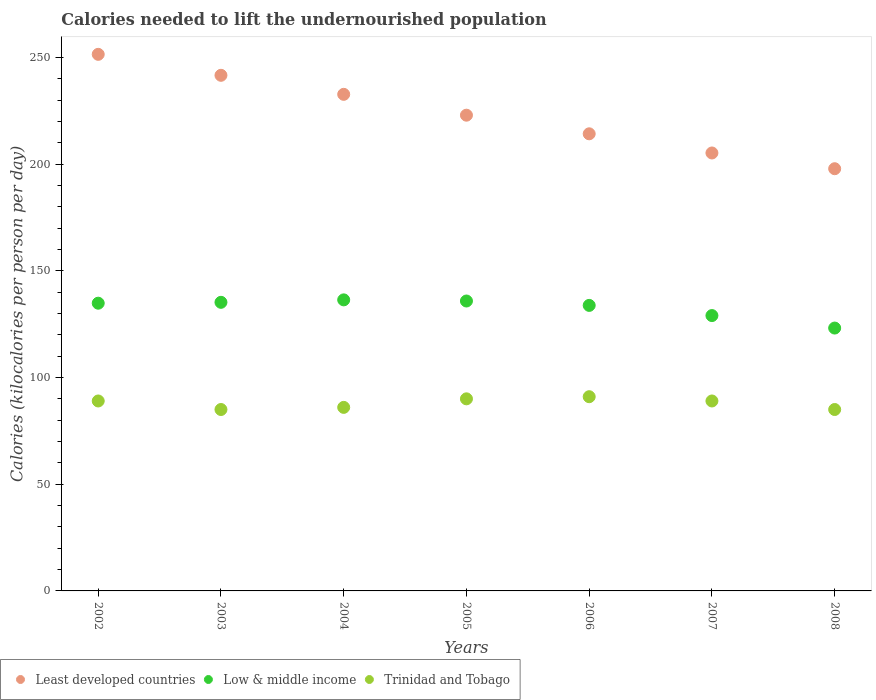How many different coloured dotlines are there?
Offer a very short reply. 3. Is the number of dotlines equal to the number of legend labels?
Offer a terse response. Yes. What is the total calories needed to lift the undernourished population in Trinidad and Tobago in 2008?
Offer a very short reply. 85. Across all years, what is the maximum total calories needed to lift the undernourished population in Trinidad and Tobago?
Your answer should be very brief. 91. Across all years, what is the minimum total calories needed to lift the undernourished population in Trinidad and Tobago?
Offer a terse response. 85. In which year was the total calories needed to lift the undernourished population in Low & middle income maximum?
Give a very brief answer. 2004. In which year was the total calories needed to lift the undernourished population in Least developed countries minimum?
Offer a very short reply. 2008. What is the total total calories needed to lift the undernourished population in Trinidad and Tobago in the graph?
Provide a succinct answer. 615. What is the difference between the total calories needed to lift the undernourished population in Least developed countries in 2006 and that in 2007?
Ensure brevity in your answer.  8.98. What is the difference between the total calories needed to lift the undernourished population in Least developed countries in 2003 and the total calories needed to lift the undernourished population in Low & middle income in 2008?
Provide a short and direct response. 118.43. What is the average total calories needed to lift the undernourished population in Trinidad and Tobago per year?
Provide a succinct answer. 87.86. In the year 2003, what is the difference between the total calories needed to lift the undernourished population in Least developed countries and total calories needed to lift the undernourished population in Trinidad and Tobago?
Your answer should be compact. 156.59. In how many years, is the total calories needed to lift the undernourished population in Trinidad and Tobago greater than 40 kilocalories?
Your answer should be very brief. 7. What is the ratio of the total calories needed to lift the undernourished population in Least developed countries in 2003 to that in 2006?
Ensure brevity in your answer.  1.13. Is the difference between the total calories needed to lift the undernourished population in Least developed countries in 2003 and 2006 greater than the difference between the total calories needed to lift the undernourished population in Trinidad and Tobago in 2003 and 2006?
Ensure brevity in your answer.  Yes. What is the difference between the highest and the lowest total calories needed to lift the undernourished population in Least developed countries?
Your response must be concise. 53.59. In how many years, is the total calories needed to lift the undernourished population in Trinidad and Tobago greater than the average total calories needed to lift the undernourished population in Trinidad and Tobago taken over all years?
Your answer should be compact. 4. Is the sum of the total calories needed to lift the undernourished population in Low & middle income in 2003 and 2004 greater than the maximum total calories needed to lift the undernourished population in Trinidad and Tobago across all years?
Make the answer very short. Yes. Is it the case that in every year, the sum of the total calories needed to lift the undernourished population in Trinidad and Tobago and total calories needed to lift the undernourished population in Low & middle income  is greater than the total calories needed to lift the undernourished population in Least developed countries?
Ensure brevity in your answer.  No. Does the total calories needed to lift the undernourished population in Low & middle income monotonically increase over the years?
Your answer should be very brief. No. How many dotlines are there?
Make the answer very short. 3. What is the difference between two consecutive major ticks on the Y-axis?
Keep it short and to the point. 50. Are the values on the major ticks of Y-axis written in scientific E-notation?
Keep it short and to the point. No. Does the graph contain any zero values?
Provide a short and direct response. No. What is the title of the graph?
Your response must be concise. Calories needed to lift the undernourished population. Does "Costa Rica" appear as one of the legend labels in the graph?
Your answer should be very brief. No. What is the label or title of the X-axis?
Your answer should be very brief. Years. What is the label or title of the Y-axis?
Provide a short and direct response. Calories (kilocalories per person per day). What is the Calories (kilocalories per person per day) in Least developed countries in 2002?
Your response must be concise. 251.42. What is the Calories (kilocalories per person per day) of Low & middle income in 2002?
Your answer should be very brief. 134.81. What is the Calories (kilocalories per person per day) in Trinidad and Tobago in 2002?
Give a very brief answer. 89. What is the Calories (kilocalories per person per day) of Least developed countries in 2003?
Provide a short and direct response. 241.59. What is the Calories (kilocalories per person per day) in Low & middle income in 2003?
Offer a very short reply. 135.22. What is the Calories (kilocalories per person per day) of Least developed countries in 2004?
Offer a terse response. 232.67. What is the Calories (kilocalories per person per day) of Low & middle income in 2004?
Keep it short and to the point. 136.37. What is the Calories (kilocalories per person per day) of Least developed countries in 2005?
Your answer should be compact. 222.9. What is the Calories (kilocalories per person per day) in Low & middle income in 2005?
Provide a succinct answer. 135.84. What is the Calories (kilocalories per person per day) in Least developed countries in 2006?
Make the answer very short. 214.18. What is the Calories (kilocalories per person per day) in Low & middle income in 2006?
Keep it short and to the point. 133.78. What is the Calories (kilocalories per person per day) of Trinidad and Tobago in 2006?
Provide a succinct answer. 91. What is the Calories (kilocalories per person per day) in Least developed countries in 2007?
Ensure brevity in your answer.  205.2. What is the Calories (kilocalories per person per day) in Low & middle income in 2007?
Provide a short and direct response. 129.01. What is the Calories (kilocalories per person per day) of Trinidad and Tobago in 2007?
Make the answer very short. 89. What is the Calories (kilocalories per person per day) in Least developed countries in 2008?
Your answer should be compact. 197.82. What is the Calories (kilocalories per person per day) in Low & middle income in 2008?
Keep it short and to the point. 123.16. What is the Calories (kilocalories per person per day) in Trinidad and Tobago in 2008?
Offer a very short reply. 85. Across all years, what is the maximum Calories (kilocalories per person per day) in Least developed countries?
Make the answer very short. 251.42. Across all years, what is the maximum Calories (kilocalories per person per day) of Low & middle income?
Your answer should be compact. 136.37. Across all years, what is the maximum Calories (kilocalories per person per day) of Trinidad and Tobago?
Provide a succinct answer. 91. Across all years, what is the minimum Calories (kilocalories per person per day) in Least developed countries?
Make the answer very short. 197.82. Across all years, what is the minimum Calories (kilocalories per person per day) of Low & middle income?
Offer a very short reply. 123.16. What is the total Calories (kilocalories per person per day) in Least developed countries in the graph?
Provide a short and direct response. 1565.79. What is the total Calories (kilocalories per person per day) in Low & middle income in the graph?
Your answer should be compact. 928.21. What is the total Calories (kilocalories per person per day) in Trinidad and Tobago in the graph?
Provide a succinct answer. 615. What is the difference between the Calories (kilocalories per person per day) of Least developed countries in 2002 and that in 2003?
Offer a terse response. 9.83. What is the difference between the Calories (kilocalories per person per day) in Low & middle income in 2002 and that in 2003?
Make the answer very short. -0.41. What is the difference between the Calories (kilocalories per person per day) of Least developed countries in 2002 and that in 2004?
Make the answer very short. 18.74. What is the difference between the Calories (kilocalories per person per day) of Low & middle income in 2002 and that in 2004?
Offer a terse response. -1.56. What is the difference between the Calories (kilocalories per person per day) in Least developed countries in 2002 and that in 2005?
Provide a succinct answer. 28.51. What is the difference between the Calories (kilocalories per person per day) in Low & middle income in 2002 and that in 2005?
Offer a terse response. -1.03. What is the difference between the Calories (kilocalories per person per day) in Least developed countries in 2002 and that in 2006?
Give a very brief answer. 37.24. What is the difference between the Calories (kilocalories per person per day) in Low & middle income in 2002 and that in 2006?
Make the answer very short. 1.03. What is the difference between the Calories (kilocalories per person per day) of Least developed countries in 2002 and that in 2007?
Ensure brevity in your answer.  46.22. What is the difference between the Calories (kilocalories per person per day) in Low & middle income in 2002 and that in 2007?
Your response must be concise. 5.8. What is the difference between the Calories (kilocalories per person per day) of Trinidad and Tobago in 2002 and that in 2007?
Your answer should be very brief. 0. What is the difference between the Calories (kilocalories per person per day) in Least developed countries in 2002 and that in 2008?
Your response must be concise. 53.59. What is the difference between the Calories (kilocalories per person per day) in Low & middle income in 2002 and that in 2008?
Your answer should be compact. 11.65. What is the difference between the Calories (kilocalories per person per day) of Trinidad and Tobago in 2002 and that in 2008?
Offer a very short reply. 4. What is the difference between the Calories (kilocalories per person per day) in Least developed countries in 2003 and that in 2004?
Your answer should be very brief. 8.92. What is the difference between the Calories (kilocalories per person per day) of Low & middle income in 2003 and that in 2004?
Your answer should be very brief. -1.15. What is the difference between the Calories (kilocalories per person per day) of Least developed countries in 2003 and that in 2005?
Provide a short and direct response. 18.69. What is the difference between the Calories (kilocalories per person per day) in Low & middle income in 2003 and that in 2005?
Your answer should be compact. -0.62. What is the difference between the Calories (kilocalories per person per day) in Trinidad and Tobago in 2003 and that in 2005?
Offer a terse response. -5. What is the difference between the Calories (kilocalories per person per day) in Least developed countries in 2003 and that in 2006?
Your answer should be very brief. 27.41. What is the difference between the Calories (kilocalories per person per day) of Low & middle income in 2003 and that in 2006?
Your answer should be very brief. 1.44. What is the difference between the Calories (kilocalories per person per day) of Trinidad and Tobago in 2003 and that in 2006?
Make the answer very short. -6. What is the difference between the Calories (kilocalories per person per day) in Least developed countries in 2003 and that in 2007?
Give a very brief answer. 36.39. What is the difference between the Calories (kilocalories per person per day) of Low & middle income in 2003 and that in 2007?
Your answer should be very brief. 6.21. What is the difference between the Calories (kilocalories per person per day) in Least developed countries in 2003 and that in 2008?
Your answer should be very brief. 43.77. What is the difference between the Calories (kilocalories per person per day) of Low & middle income in 2003 and that in 2008?
Provide a short and direct response. 12.06. What is the difference between the Calories (kilocalories per person per day) in Trinidad and Tobago in 2003 and that in 2008?
Keep it short and to the point. 0. What is the difference between the Calories (kilocalories per person per day) in Least developed countries in 2004 and that in 2005?
Offer a terse response. 9.77. What is the difference between the Calories (kilocalories per person per day) in Low & middle income in 2004 and that in 2005?
Provide a succinct answer. 0.54. What is the difference between the Calories (kilocalories per person per day) in Least developed countries in 2004 and that in 2006?
Provide a short and direct response. 18.49. What is the difference between the Calories (kilocalories per person per day) of Low & middle income in 2004 and that in 2006?
Your answer should be very brief. 2.59. What is the difference between the Calories (kilocalories per person per day) of Least developed countries in 2004 and that in 2007?
Offer a very short reply. 27.47. What is the difference between the Calories (kilocalories per person per day) in Low & middle income in 2004 and that in 2007?
Give a very brief answer. 7.36. What is the difference between the Calories (kilocalories per person per day) of Trinidad and Tobago in 2004 and that in 2007?
Ensure brevity in your answer.  -3. What is the difference between the Calories (kilocalories per person per day) of Least developed countries in 2004 and that in 2008?
Your answer should be very brief. 34.85. What is the difference between the Calories (kilocalories per person per day) in Low & middle income in 2004 and that in 2008?
Offer a very short reply. 13.21. What is the difference between the Calories (kilocalories per person per day) in Trinidad and Tobago in 2004 and that in 2008?
Provide a short and direct response. 1. What is the difference between the Calories (kilocalories per person per day) in Least developed countries in 2005 and that in 2006?
Give a very brief answer. 8.72. What is the difference between the Calories (kilocalories per person per day) in Low & middle income in 2005 and that in 2006?
Your response must be concise. 2.06. What is the difference between the Calories (kilocalories per person per day) in Least developed countries in 2005 and that in 2007?
Provide a succinct answer. 17.7. What is the difference between the Calories (kilocalories per person per day) in Low & middle income in 2005 and that in 2007?
Ensure brevity in your answer.  6.83. What is the difference between the Calories (kilocalories per person per day) of Trinidad and Tobago in 2005 and that in 2007?
Keep it short and to the point. 1. What is the difference between the Calories (kilocalories per person per day) in Least developed countries in 2005 and that in 2008?
Your response must be concise. 25.08. What is the difference between the Calories (kilocalories per person per day) of Low & middle income in 2005 and that in 2008?
Make the answer very short. 12.68. What is the difference between the Calories (kilocalories per person per day) of Least developed countries in 2006 and that in 2007?
Provide a short and direct response. 8.98. What is the difference between the Calories (kilocalories per person per day) in Low & middle income in 2006 and that in 2007?
Make the answer very short. 4.77. What is the difference between the Calories (kilocalories per person per day) in Trinidad and Tobago in 2006 and that in 2007?
Offer a very short reply. 2. What is the difference between the Calories (kilocalories per person per day) of Least developed countries in 2006 and that in 2008?
Offer a terse response. 16.36. What is the difference between the Calories (kilocalories per person per day) in Low & middle income in 2006 and that in 2008?
Offer a very short reply. 10.62. What is the difference between the Calories (kilocalories per person per day) of Least developed countries in 2007 and that in 2008?
Provide a succinct answer. 7.38. What is the difference between the Calories (kilocalories per person per day) of Low & middle income in 2007 and that in 2008?
Give a very brief answer. 5.85. What is the difference between the Calories (kilocalories per person per day) in Least developed countries in 2002 and the Calories (kilocalories per person per day) in Low & middle income in 2003?
Provide a succinct answer. 116.19. What is the difference between the Calories (kilocalories per person per day) in Least developed countries in 2002 and the Calories (kilocalories per person per day) in Trinidad and Tobago in 2003?
Provide a short and direct response. 166.42. What is the difference between the Calories (kilocalories per person per day) of Low & middle income in 2002 and the Calories (kilocalories per person per day) of Trinidad and Tobago in 2003?
Your answer should be compact. 49.81. What is the difference between the Calories (kilocalories per person per day) of Least developed countries in 2002 and the Calories (kilocalories per person per day) of Low & middle income in 2004?
Provide a short and direct response. 115.04. What is the difference between the Calories (kilocalories per person per day) of Least developed countries in 2002 and the Calories (kilocalories per person per day) of Trinidad and Tobago in 2004?
Provide a short and direct response. 165.42. What is the difference between the Calories (kilocalories per person per day) in Low & middle income in 2002 and the Calories (kilocalories per person per day) in Trinidad and Tobago in 2004?
Offer a very short reply. 48.81. What is the difference between the Calories (kilocalories per person per day) in Least developed countries in 2002 and the Calories (kilocalories per person per day) in Low & middle income in 2005?
Provide a short and direct response. 115.58. What is the difference between the Calories (kilocalories per person per day) of Least developed countries in 2002 and the Calories (kilocalories per person per day) of Trinidad and Tobago in 2005?
Make the answer very short. 161.42. What is the difference between the Calories (kilocalories per person per day) in Low & middle income in 2002 and the Calories (kilocalories per person per day) in Trinidad and Tobago in 2005?
Keep it short and to the point. 44.81. What is the difference between the Calories (kilocalories per person per day) in Least developed countries in 2002 and the Calories (kilocalories per person per day) in Low & middle income in 2006?
Make the answer very short. 117.63. What is the difference between the Calories (kilocalories per person per day) in Least developed countries in 2002 and the Calories (kilocalories per person per day) in Trinidad and Tobago in 2006?
Keep it short and to the point. 160.42. What is the difference between the Calories (kilocalories per person per day) of Low & middle income in 2002 and the Calories (kilocalories per person per day) of Trinidad and Tobago in 2006?
Your response must be concise. 43.81. What is the difference between the Calories (kilocalories per person per day) in Least developed countries in 2002 and the Calories (kilocalories per person per day) in Low & middle income in 2007?
Offer a terse response. 122.4. What is the difference between the Calories (kilocalories per person per day) in Least developed countries in 2002 and the Calories (kilocalories per person per day) in Trinidad and Tobago in 2007?
Ensure brevity in your answer.  162.42. What is the difference between the Calories (kilocalories per person per day) in Low & middle income in 2002 and the Calories (kilocalories per person per day) in Trinidad and Tobago in 2007?
Give a very brief answer. 45.81. What is the difference between the Calories (kilocalories per person per day) of Least developed countries in 2002 and the Calories (kilocalories per person per day) of Low & middle income in 2008?
Give a very brief answer. 128.25. What is the difference between the Calories (kilocalories per person per day) of Least developed countries in 2002 and the Calories (kilocalories per person per day) of Trinidad and Tobago in 2008?
Make the answer very short. 166.42. What is the difference between the Calories (kilocalories per person per day) of Low & middle income in 2002 and the Calories (kilocalories per person per day) of Trinidad and Tobago in 2008?
Ensure brevity in your answer.  49.81. What is the difference between the Calories (kilocalories per person per day) of Least developed countries in 2003 and the Calories (kilocalories per person per day) of Low & middle income in 2004?
Your response must be concise. 105.22. What is the difference between the Calories (kilocalories per person per day) of Least developed countries in 2003 and the Calories (kilocalories per person per day) of Trinidad and Tobago in 2004?
Provide a succinct answer. 155.59. What is the difference between the Calories (kilocalories per person per day) in Low & middle income in 2003 and the Calories (kilocalories per person per day) in Trinidad and Tobago in 2004?
Your response must be concise. 49.22. What is the difference between the Calories (kilocalories per person per day) in Least developed countries in 2003 and the Calories (kilocalories per person per day) in Low & middle income in 2005?
Make the answer very short. 105.75. What is the difference between the Calories (kilocalories per person per day) in Least developed countries in 2003 and the Calories (kilocalories per person per day) in Trinidad and Tobago in 2005?
Your response must be concise. 151.59. What is the difference between the Calories (kilocalories per person per day) of Low & middle income in 2003 and the Calories (kilocalories per person per day) of Trinidad and Tobago in 2005?
Your answer should be very brief. 45.22. What is the difference between the Calories (kilocalories per person per day) of Least developed countries in 2003 and the Calories (kilocalories per person per day) of Low & middle income in 2006?
Offer a very short reply. 107.81. What is the difference between the Calories (kilocalories per person per day) of Least developed countries in 2003 and the Calories (kilocalories per person per day) of Trinidad and Tobago in 2006?
Give a very brief answer. 150.59. What is the difference between the Calories (kilocalories per person per day) in Low & middle income in 2003 and the Calories (kilocalories per person per day) in Trinidad and Tobago in 2006?
Your answer should be very brief. 44.22. What is the difference between the Calories (kilocalories per person per day) in Least developed countries in 2003 and the Calories (kilocalories per person per day) in Low & middle income in 2007?
Your answer should be compact. 112.58. What is the difference between the Calories (kilocalories per person per day) of Least developed countries in 2003 and the Calories (kilocalories per person per day) of Trinidad and Tobago in 2007?
Your answer should be compact. 152.59. What is the difference between the Calories (kilocalories per person per day) in Low & middle income in 2003 and the Calories (kilocalories per person per day) in Trinidad and Tobago in 2007?
Your answer should be very brief. 46.22. What is the difference between the Calories (kilocalories per person per day) in Least developed countries in 2003 and the Calories (kilocalories per person per day) in Low & middle income in 2008?
Make the answer very short. 118.43. What is the difference between the Calories (kilocalories per person per day) in Least developed countries in 2003 and the Calories (kilocalories per person per day) in Trinidad and Tobago in 2008?
Provide a short and direct response. 156.59. What is the difference between the Calories (kilocalories per person per day) of Low & middle income in 2003 and the Calories (kilocalories per person per day) of Trinidad and Tobago in 2008?
Provide a short and direct response. 50.22. What is the difference between the Calories (kilocalories per person per day) of Least developed countries in 2004 and the Calories (kilocalories per person per day) of Low & middle income in 2005?
Offer a very short reply. 96.83. What is the difference between the Calories (kilocalories per person per day) in Least developed countries in 2004 and the Calories (kilocalories per person per day) in Trinidad and Tobago in 2005?
Offer a very short reply. 142.67. What is the difference between the Calories (kilocalories per person per day) in Low & middle income in 2004 and the Calories (kilocalories per person per day) in Trinidad and Tobago in 2005?
Ensure brevity in your answer.  46.38. What is the difference between the Calories (kilocalories per person per day) in Least developed countries in 2004 and the Calories (kilocalories per person per day) in Low & middle income in 2006?
Provide a succinct answer. 98.89. What is the difference between the Calories (kilocalories per person per day) of Least developed countries in 2004 and the Calories (kilocalories per person per day) of Trinidad and Tobago in 2006?
Your response must be concise. 141.67. What is the difference between the Calories (kilocalories per person per day) in Low & middle income in 2004 and the Calories (kilocalories per person per day) in Trinidad and Tobago in 2006?
Make the answer very short. 45.38. What is the difference between the Calories (kilocalories per person per day) of Least developed countries in 2004 and the Calories (kilocalories per person per day) of Low & middle income in 2007?
Ensure brevity in your answer.  103.66. What is the difference between the Calories (kilocalories per person per day) in Least developed countries in 2004 and the Calories (kilocalories per person per day) in Trinidad and Tobago in 2007?
Your answer should be compact. 143.67. What is the difference between the Calories (kilocalories per person per day) in Low & middle income in 2004 and the Calories (kilocalories per person per day) in Trinidad and Tobago in 2007?
Offer a terse response. 47.38. What is the difference between the Calories (kilocalories per person per day) of Least developed countries in 2004 and the Calories (kilocalories per person per day) of Low & middle income in 2008?
Offer a very short reply. 109.51. What is the difference between the Calories (kilocalories per person per day) of Least developed countries in 2004 and the Calories (kilocalories per person per day) of Trinidad and Tobago in 2008?
Your response must be concise. 147.67. What is the difference between the Calories (kilocalories per person per day) in Low & middle income in 2004 and the Calories (kilocalories per person per day) in Trinidad and Tobago in 2008?
Make the answer very short. 51.38. What is the difference between the Calories (kilocalories per person per day) of Least developed countries in 2005 and the Calories (kilocalories per person per day) of Low & middle income in 2006?
Your response must be concise. 89.12. What is the difference between the Calories (kilocalories per person per day) of Least developed countries in 2005 and the Calories (kilocalories per person per day) of Trinidad and Tobago in 2006?
Make the answer very short. 131.9. What is the difference between the Calories (kilocalories per person per day) in Low & middle income in 2005 and the Calories (kilocalories per person per day) in Trinidad and Tobago in 2006?
Your answer should be compact. 44.84. What is the difference between the Calories (kilocalories per person per day) in Least developed countries in 2005 and the Calories (kilocalories per person per day) in Low & middle income in 2007?
Make the answer very short. 93.89. What is the difference between the Calories (kilocalories per person per day) in Least developed countries in 2005 and the Calories (kilocalories per person per day) in Trinidad and Tobago in 2007?
Give a very brief answer. 133.9. What is the difference between the Calories (kilocalories per person per day) in Low & middle income in 2005 and the Calories (kilocalories per person per day) in Trinidad and Tobago in 2007?
Your answer should be very brief. 46.84. What is the difference between the Calories (kilocalories per person per day) in Least developed countries in 2005 and the Calories (kilocalories per person per day) in Low & middle income in 2008?
Offer a terse response. 99.74. What is the difference between the Calories (kilocalories per person per day) of Least developed countries in 2005 and the Calories (kilocalories per person per day) of Trinidad and Tobago in 2008?
Give a very brief answer. 137.9. What is the difference between the Calories (kilocalories per person per day) of Low & middle income in 2005 and the Calories (kilocalories per person per day) of Trinidad and Tobago in 2008?
Give a very brief answer. 50.84. What is the difference between the Calories (kilocalories per person per day) of Least developed countries in 2006 and the Calories (kilocalories per person per day) of Low & middle income in 2007?
Your response must be concise. 85.17. What is the difference between the Calories (kilocalories per person per day) in Least developed countries in 2006 and the Calories (kilocalories per person per day) in Trinidad and Tobago in 2007?
Offer a very short reply. 125.18. What is the difference between the Calories (kilocalories per person per day) of Low & middle income in 2006 and the Calories (kilocalories per person per day) of Trinidad and Tobago in 2007?
Provide a short and direct response. 44.78. What is the difference between the Calories (kilocalories per person per day) in Least developed countries in 2006 and the Calories (kilocalories per person per day) in Low & middle income in 2008?
Offer a very short reply. 91.02. What is the difference between the Calories (kilocalories per person per day) in Least developed countries in 2006 and the Calories (kilocalories per person per day) in Trinidad and Tobago in 2008?
Your answer should be very brief. 129.18. What is the difference between the Calories (kilocalories per person per day) in Low & middle income in 2006 and the Calories (kilocalories per person per day) in Trinidad and Tobago in 2008?
Provide a short and direct response. 48.78. What is the difference between the Calories (kilocalories per person per day) in Least developed countries in 2007 and the Calories (kilocalories per person per day) in Low & middle income in 2008?
Your response must be concise. 82.04. What is the difference between the Calories (kilocalories per person per day) in Least developed countries in 2007 and the Calories (kilocalories per person per day) in Trinidad and Tobago in 2008?
Provide a succinct answer. 120.2. What is the difference between the Calories (kilocalories per person per day) in Low & middle income in 2007 and the Calories (kilocalories per person per day) in Trinidad and Tobago in 2008?
Your response must be concise. 44.01. What is the average Calories (kilocalories per person per day) of Least developed countries per year?
Offer a terse response. 223.68. What is the average Calories (kilocalories per person per day) in Low & middle income per year?
Your answer should be very brief. 132.6. What is the average Calories (kilocalories per person per day) of Trinidad and Tobago per year?
Your answer should be very brief. 87.86. In the year 2002, what is the difference between the Calories (kilocalories per person per day) in Least developed countries and Calories (kilocalories per person per day) in Low & middle income?
Your answer should be very brief. 116.61. In the year 2002, what is the difference between the Calories (kilocalories per person per day) in Least developed countries and Calories (kilocalories per person per day) in Trinidad and Tobago?
Your answer should be very brief. 162.42. In the year 2002, what is the difference between the Calories (kilocalories per person per day) in Low & middle income and Calories (kilocalories per person per day) in Trinidad and Tobago?
Make the answer very short. 45.81. In the year 2003, what is the difference between the Calories (kilocalories per person per day) of Least developed countries and Calories (kilocalories per person per day) of Low & middle income?
Give a very brief answer. 106.37. In the year 2003, what is the difference between the Calories (kilocalories per person per day) in Least developed countries and Calories (kilocalories per person per day) in Trinidad and Tobago?
Your response must be concise. 156.59. In the year 2003, what is the difference between the Calories (kilocalories per person per day) of Low & middle income and Calories (kilocalories per person per day) of Trinidad and Tobago?
Your response must be concise. 50.22. In the year 2004, what is the difference between the Calories (kilocalories per person per day) in Least developed countries and Calories (kilocalories per person per day) in Low & middle income?
Provide a short and direct response. 96.3. In the year 2004, what is the difference between the Calories (kilocalories per person per day) in Least developed countries and Calories (kilocalories per person per day) in Trinidad and Tobago?
Give a very brief answer. 146.67. In the year 2004, what is the difference between the Calories (kilocalories per person per day) in Low & middle income and Calories (kilocalories per person per day) in Trinidad and Tobago?
Provide a succinct answer. 50.38. In the year 2005, what is the difference between the Calories (kilocalories per person per day) in Least developed countries and Calories (kilocalories per person per day) in Low & middle income?
Offer a terse response. 87.06. In the year 2005, what is the difference between the Calories (kilocalories per person per day) of Least developed countries and Calories (kilocalories per person per day) of Trinidad and Tobago?
Your answer should be very brief. 132.9. In the year 2005, what is the difference between the Calories (kilocalories per person per day) of Low & middle income and Calories (kilocalories per person per day) of Trinidad and Tobago?
Give a very brief answer. 45.84. In the year 2006, what is the difference between the Calories (kilocalories per person per day) of Least developed countries and Calories (kilocalories per person per day) of Low & middle income?
Ensure brevity in your answer.  80.4. In the year 2006, what is the difference between the Calories (kilocalories per person per day) of Least developed countries and Calories (kilocalories per person per day) of Trinidad and Tobago?
Give a very brief answer. 123.18. In the year 2006, what is the difference between the Calories (kilocalories per person per day) of Low & middle income and Calories (kilocalories per person per day) of Trinidad and Tobago?
Keep it short and to the point. 42.78. In the year 2007, what is the difference between the Calories (kilocalories per person per day) of Least developed countries and Calories (kilocalories per person per day) of Low & middle income?
Make the answer very short. 76.19. In the year 2007, what is the difference between the Calories (kilocalories per person per day) in Least developed countries and Calories (kilocalories per person per day) in Trinidad and Tobago?
Your answer should be compact. 116.2. In the year 2007, what is the difference between the Calories (kilocalories per person per day) of Low & middle income and Calories (kilocalories per person per day) of Trinidad and Tobago?
Offer a terse response. 40.01. In the year 2008, what is the difference between the Calories (kilocalories per person per day) of Least developed countries and Calories (kilocalories per person per day) of Low & middle income?
Your response must be concise. 74.66. In the year 2008, what is the difference between the Calories (kilocalories per person per day) in Least developed countries and Calories (kilocalories per person per day) in Trinidad and Tobago?
Ensure brevity in your answer.  112.82. In the year 2008, what is the difference between the Calories (kilocalories per person per day) in Low & middle income and Calories (kilocalories per person per day) in Trinidad and Tobago?
Provide a succinct answer. 38.16. What is the ratio of the Calories (kilocalories per person per day) of Least developed countries in 2002 to that in 2003?
Provide a succinct answer. 1.04. What is the ratio of the Calories (kilocalories per person per day) of Trinidad and Tobago in 2002 to that in 2003?
Your answer should be very brief. 1.05. What is the ratio of the Calories (kilocalories per person per day) of Least developed countries in 2002 to that in 2004?
Your answer should be very brief. 1.08. What is the ratio of the Calories (kilocalories per person per day) of Trinidad and Tobago in 2002 to that in 2004?
Your response must be concise. 1.03. What is the ratio of the Calories (kilocalories per person per day) of Least developed countries in 2002 to that in 2005?
Your answer should be very brief. 1.13. What is the ratio of the Calories (kilocalories per person per day) of Low & middle income in 2002 to that in 2005?
Your answer should be very brief. 0.99. What is the ratio of the Calories (kilocalories per person per day) of Trinidad and Tobago in 2002 to that in 2005?
Ensure brevity in your answer.  0.99. What is the ratio of the Calories (kilocalories per person per day) in Least developed countries in 2002 to that in 2006?
Your answer should be very brief. 1.17. What is the ratio of the Calories (kilocalories per person per day) of Low & middle income in 2002 to that in 2006?
Offer a very short reply. 1.01. What is the ratio of the Calories (kilocalories per person per day) of Trinidad and Tobago in 2002 to that in 2006?
Your response must be concise. 0.98. What is the ratio of the Calories (kilocalories per person per day) of Least developed countries in 2002 to that in 2007?
Provide a short and direct response. 1.23. What is the ratio of the Calories (kilocalories per person per day) in Low & middle income in 2002 to that in 2007?
Your response must be concise. 1.04. What is the ratio of the Calories (kilocalories per person per day) in Least developed countries in 2002 to that in 2008?
Offer a terse response. 1.27. What is the ratio of the Calories (kilocalories per person per day) of Low & middle income in 2002 to that in 2008?
Ensure brevity in your answer.  1.09. What is the ratio of the Calories (kilocalories per person per day) in Trinidad and Tobago in 2002 to that in 2008?
Keep it short and to the point. 1.05. What is the ratio of the Calories (kilocalories per person per day) of Least developed countries in 2003 to that in 2004?
Ensure brevity in your answer.  1.04. What is the ratio of the Calories (kilocalories per person per day) in Trinidad and Tobago in 2003 to that in 2004?
Offer a very short reply. 0.99. What is the ratio of the Calories (kilocalories per person per day) in Least developed countries in 2003 to that in 2005?
Your answer should be compact. 1.08. What is the ratio of the Calories (kilocalories per person per day) of Low & middle income in 2003 to that in 2005?
Provide a short and direct response. 1. What is the ratio of the Calories (kilocalories per person per day) in Trinidad and Tobago in 2003 to that in 2005?
Provide a short and direct response. 0.94. What is the ratio of the Calories (kilocalories per person per day) in Least developed countries in 2003 to that in 2006?
Your response must be concise. 1.13. What is the ratio of the Calories (kilocalories per person per day) of Low & middle income in 2003 to that in 2006?
Your answer should be compact. 1.01. What is the ratio of the Calories (kilocalories per person per day) of Trinidad and Tobago in 2003 to that in 2006?
Give a very brief answer. 0.93. What is the ratio of the Calories (kilocalories per person per day) of Least developed countries in 2003 to that in 2007?
Your response must be concise. 1.18. What is the ratio of the Calories (kilocalories per person per day) of Low & middle income in 2003 to that in 2007?
Offer a very short reply. 1.05. What is the ratio of the Calories (kilocalories per person per day) in Trinidad and Tobago in 2003 to that in 2007?
Provide a succinct answer. 0.96. What is the ratio of the Calories (kilocalories per person per day) in Least developed countries in 2003 to that in 2008?
Keep it short and to the point. 1.22. What is the ratio of the Calories (kilocalories per person per day) in Low & middle income in 2003 to that in 2008?
Provide a short and direct response. 1.1. What is the ratio of the Calories (kilocalories per person per day) in Least developed countries in 2004 to that in 2005?
Make the answer very short. 1.04. What is the ratio of the Calories (kilocalories per person per day) in Low & middle income in 2004 to that in 2005?
Provide a short and direct response. 1. What is the ratio of the Calories (kilocalories per person per day) in Trinidad and Tobago in 2004 to that in 2005?
Offer a very short reply. 0.96. What is the ratio of the Calories (kilocalories per person per day) in Least developed countries in 2004 to that in 2006?
Make the answer very short. 1.09. What is the ratio of the Calories (kilocalories per person per day) of Low & middle income in 2004 to that in 2006?
Provide a short and direct response. 1.02. What is the ratio of the Calories (kilocalories per person per day) in Trinidad and Tobago in 2004 to that in 2006?
Keep it short and to the point. 0.95. What is the ratio of the Calories (kilocalories per person per day) in Least developed countries in 2004 to that in 2007?
Your answer should be very brief. 1.13. What is the ratio of the Calories (kilocalories per person per day) of Low & middle income in 2004 to that in 2007?
Your answer should be compact. 1.06. What is the ratio of the Calories (kilocalories per person per day) of Trinidad and Tobago in 2004 to that in 2007?
Give a very brief answer. 0.97. What is the ratio of the Calories (kilocalories per person per day) in Least developed countries in 2004 to that in 2008?
Your response must be concise. 1.18. What is the ratio of the Calories (kilocalories per person per day) in Low & middle income in 2004 to that in 2008?
Provide a short and direct response. 1.11. What is the ratio of the Calories (kilocalories per person per day) in Trinidad and Tobago in 2004 to that in 2008?
Offer a terse response. 1.01. What is the ratio of the Calories (kilocalories per person per day) in Least developed countries in 2005 to that in 2006?
Keep it short and to the point. 1.04. What is the ratio of the Calories (kilocalories per person per day) of Low & middle income in 2005 to that in 2006?
Offer a very short reply. 1.02. What is the ratio of the Calories (kilocalories per person per day) of Trinidad and Tobago in 2005 to that in 2006?
Your answer should be compact. 0.99. What is the ratio of the Calories (kilocalories per person per day) in Least developed countries in 2005 to that in 2007?
Ensure brevity in your answer.  1.09. What is the ratio of the Calories (kilocalories per person per day) in Low & middle income in 2005 to that in 2007?
Make the answer very short. 1.05. What is the ratio of the Calories (kilocalories per person per day) of Trinidad and Tobago in 2005 to that in 2007?
Offer a very short reply. 1.01. What is the ratio of the Calories (kilocalories per person per day) of Least developed countries in 2005 to that in 2008?
Offer a terse response. 1.13. What is the ratio of the Calories (kilocalories per person per day) of Low & middle income in 2005 to that in 2008?
Ensure brevity in your answer.  1.1. What is the ratio of the Calories (kilocalories per person per day) in Trinidad and Tobago in 2005 to that in 2008?
Offer a terse response. 1.06. What is the ratio of the Calories (kilocalories per person per day) of Least developed countries in 2006 to that in 2007?
Make the answer very short. 1.04. What is the ratio of the Calories (kilocalories per person per day) of Trinidad and Tobago in 2006 to that in 2007?
Ensure brevity in your answer.  1.02. What is the ratio of the Calories (kilocalories per person per day) of Least developed countries in 2006 to that in 2008?
Offer a very short reply. 1.08. What is the ratio of the Calories (kilocalories per person per day) of Low & middle income in 2006 to that in 2008?
Provide a short and direct response. 1.09. What is the ratio of the Calories (kilocalories per person per day) of Trinidad and Tobago in 2006 to that in 2008?
Offer a terse response. 1.07. What is the ratio of the Calories (kilocalories per person per day) in Least developed countries in 2007 to that in 2008?
Your response must be concise. 1.04. What is the ratio of the Calories (kilocalories per person per day) in Low & middle income in 2007 to that in 2008?
Give a very brief answer. 1.05. What is the ratio of the Calories (kilocalories per person per day) in Trinidad and Tobago in 2007 to that in 2008?
Give a very brief answer. 1.05. What is the difference between the highest and the second highest Calories (kilocalories per person per day) in Least developed countries?
Give a very brief answer. 9.83. What is the difference between the highest and the second highest Calories (kilocalories per person per day) of Low & middle income?
Your answer should be compact. 0.54. What is the difference between the highest and the second highest Calories (kilocalories per person per day) of Trinidad and Tobago?
Keep it short and to the point. 1. What is the difference between the highest and the lowest Calories (kilocalories per person per day) of Least developed countries?
Offer a very short reply. 53.59. What is the difference between the highest and the lowest Calories (kilocalories per person per day) in Low & middle income?
Provide a short and direct response. 13.21. What is the difference between the highest and the lowest Calories (kilocalories per person per day) of Trinidad and Tobago?
Offer a very short reply. 6. 